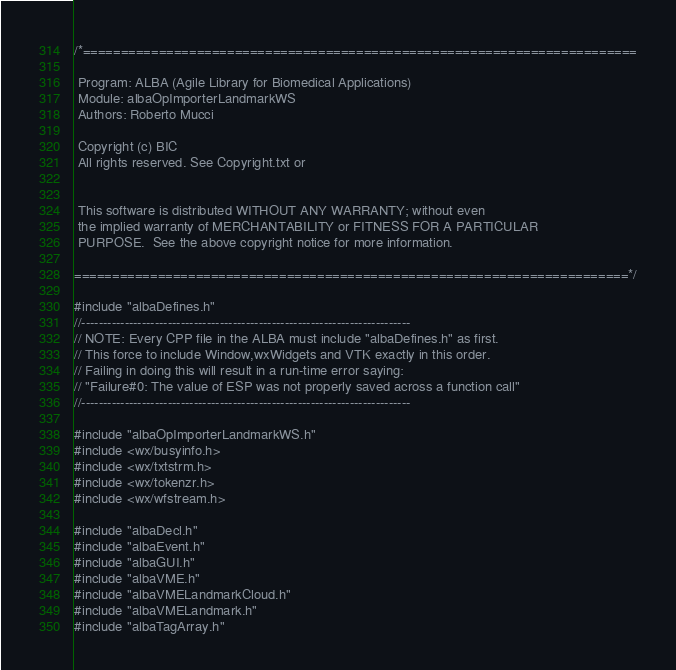Convert code to text. <code><loc_0><loc_0><loc_500><loc_500><_C++_>/*=========================================================================

 Program: ALBA (Agile Library for Biomedical Applications)
 Module: albaOpImporterLandmarkWS
 Authors: Roberto Mucci
 
 Copyright (c) BIC
 All rights reserved. See Copyright.txt or


 This software is distributed WITHOUT ANY WARRANTY; without even
 the implied warranty of MERCHANTABILITY or FITNESS FOR A PARTICULAR
 PURPOSE.  See the above copyright notice for more information.

=========================================================================*/

#include "albaDefines.h" 
//----------------------------------------------------------------------------
// NOTE: Every CPP file in the ALBA must include "albaDefines.h" as first.
// This force to include Window,wxWidgets and VTK exactly in this order.
// Failing in doing this will result in a run-time error saying:
// "Failure#0: The value of ESP was not properly saved across a function call"
//----------------------------------------------------------------------------

#include "albaOpImporterLandmarkWS.h"
#include <wx/busyinfo.h>
#include <wx/txtstrm.h>
#include <wx/tokenzr.h>
#include <wx/wfstream.h>

#include "albaDecl.h"
#include "albaEvent.h"
#include "albaGUI.h"
#include "albaVME.h"
#include "albaVMELandmarkCloud.h"
#include "albaVMELandmark.h"
#include "albaTagArray.h"</code> 